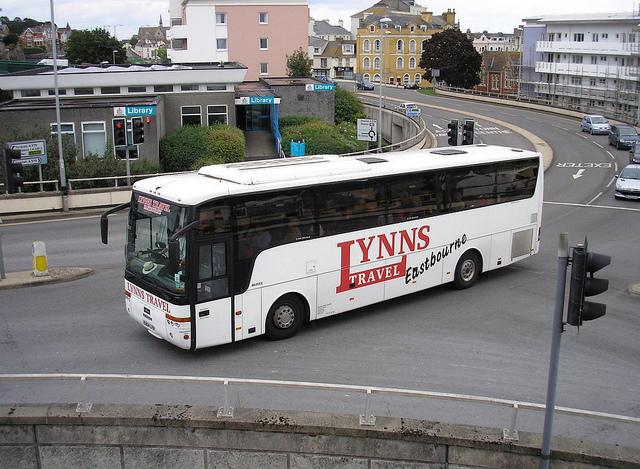How many street lights are there?
Answer briefly. 2. Is this a cul du sac?
Concise answer only. No. What company is the bus?
Concise answer only. Lynn's. 